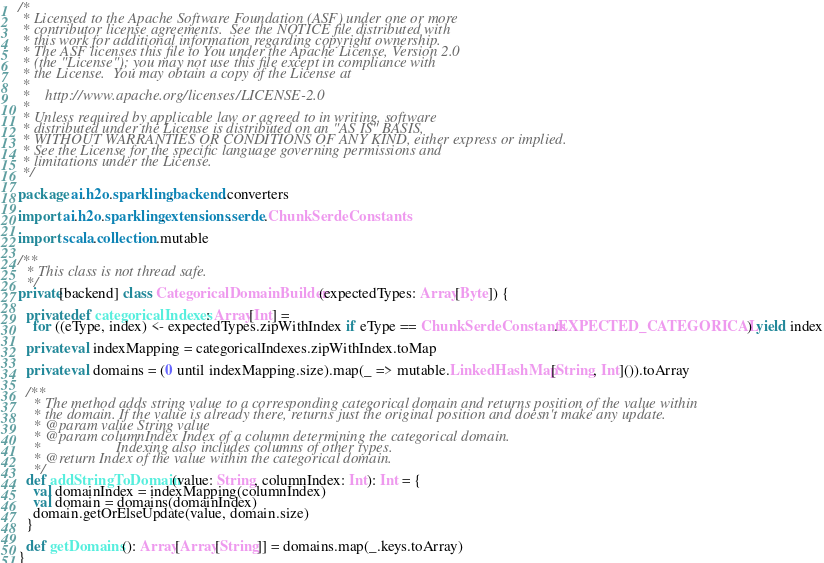<code> <loc_0><loc_0><loc_500><loc_500><_Scala_>/*
 * Licensed to the Apache Software Foundation (ASF) under one or more
 * contributor license agreements.  See the NOTICE file distributed with
 * this work for additional information regarding copyright ownership.
 * The ASF licenses this file to You under the Apache License, Version 2.0
 * (the "License"); you may not use this file except in compliance with
 * the License.  You may obtain a copy of the License at
 *
 *    http://www.apache.org/licenses/LICENSE-2.0
 *
 * Unless required by applicable law or agreed to in writing, software
 * distributed under the License is distributed on an "AS IS" BASIS,
 * WITHOUT WARRANTIES OR CONDITIONS OF ANY KIND, either express or implied.
 * See the License for the specific language governing permissions and
 * limitations under the License.
 */

package ai.h2o.sparkling.backend.converters

import ai.h2o.sparkling.extensions.serde.ChunkSerdeConstants

import scala.collection.mutable

/**
  * This class is not thread safe.
  */
private[backend] class CategoricalDomainBuilder(expectedTypes: Array[Byte]) {

  private def categoricalIndexes: Array[Int] =
    for ((eType, index) <- expectedTypes.zipWithIndex if eType == ChunkSerdeConstants.EXPECTED_CATEGORICAL) yield index

  private val indexMapping = categoricalIndexes.zipWithIndex.toMap

  private val domains = (0 until indexMapping.size).map(_ => mutable.LinkedHashMap[String, Int]()).toArray

  /**
    * The method adds string value to a corresponding categorical domain and returns position of the value within
    * the domain. If the value is already there, returns just the original position and doesn't make any update.
    * @param value String value
    * @param columnIndex Index of a column determining the categorical domain.
    *                    Indexing also includes columns of other types.
    * @return Index of the value within the categorical domain.
    */
  def addStringToDomain(value: String, columnIndex: Int): Int = {
    val domainIndex = indexMapping(columnIndex)
    val domain = domains(domainIndex)
    domain.getOrElseUpdate(value, domain.size)
  }

  def getDomains(): Array[Array[String]] = domains.map(_.keys.toArray)
}
</code> 